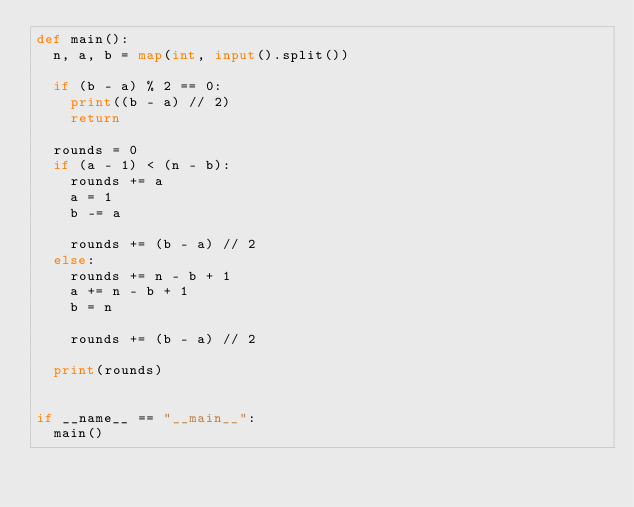Convert code to text. <code><loc_0><loc_0><loc_500><loc_500><_Python_>def main():
  n, a, b = map(int, input().split())
  
  if (b - a) % 2 == 0:
    print((b - a) // 2)
    return
  
  rounds = 0
  if (a - 1) < (n - b):
    rounds += a
    a = 1
    b -= a
    
    rounds += (b - a) // 2
  else:
    rounds += n - b + 1
    a += n - b + 1 
    b = n
    
    rounds += (b - a) // 2
    
  print(rounds)
  
  
if __name__ == "__main__":
  main()
    
</code> 